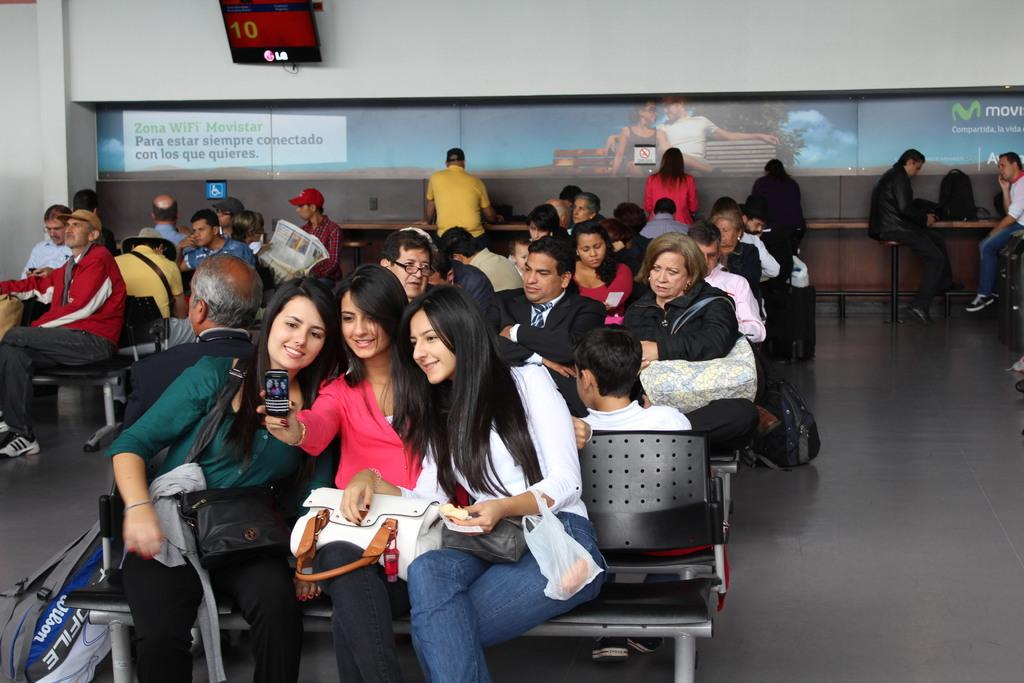How many people are in the image? There is a group of people in the image. What are some of the people in the image doing? Some people are seated on chairs, while others are standing. What can be seen near the people in the image? There is baggage visible in the image. What is in the background of the image? There is a monitor and a hoarding in the background of the image. What type of paper is being used for pleasure in the image? There is no paper or pleasure-related activity present in the image. 